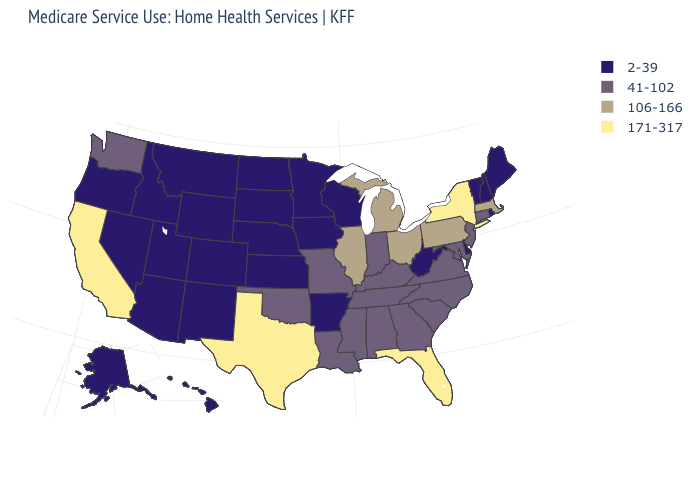What is the value of California?
Write a very short answer. 171-317. What is the value of Colorado?
Give a very brief answer. 2-39. Which states have the lowest value in the USA?
Short answer required. Alaska, Arizona, Arkansas, Colorado, Delaware, Hawaii, Idaho, Iowa, Kansas, Maine, Minnesota, Montana, Nebraska, Nevada, New Hampshire, New Mexico, North Dakota, Oregon, Rhode Island, South Dakota, Utah, Vermont, West Virginia, Wisconsin, Wyoming. Name the states that have a value in the range 41-102?
Keep it brief. Alabama, Connecticut, Georgia, Indiana, Kentucky, Louisiana, Maryland, Mississippi, Missouri, New Jersey, North Carolina, Oklahoma, South Carolina, Tennessee, Virginia, Washington. What is the value of Oregon?
Concise answer only. 2-39. How many symbols are there in the legend?
Give a very brief answer. 4. Name the states that have a value in the range 171-317?
Keep it brief. California, Florida, New York, Texas. How many symbols are there in the legend?
Keep it brief. 4. Name the states that have a value in the range 106-166?
Be succinct. Illinois, Massachusetts, Michigan, Ohio, Pennsylvania. Does Alaska have the same value as Iowa?
Quick response, please. Yes. How many symbols are there in the legend?
Short answer required. 4. What is the value of Oregon?
Short answer required. 2-39. What is the value of Nevada?
Quick response, please. 2-39. Does Louisiana have the lowest value in the USA?
Be succinct. No. What is the value of California?
Concise answer only. 171-317. 